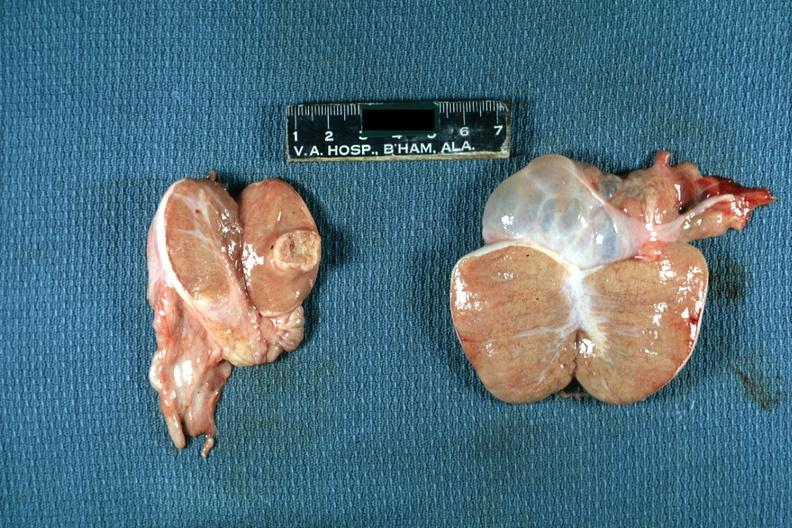what is present?
Answer the question using a single word or phrase. Testicle 